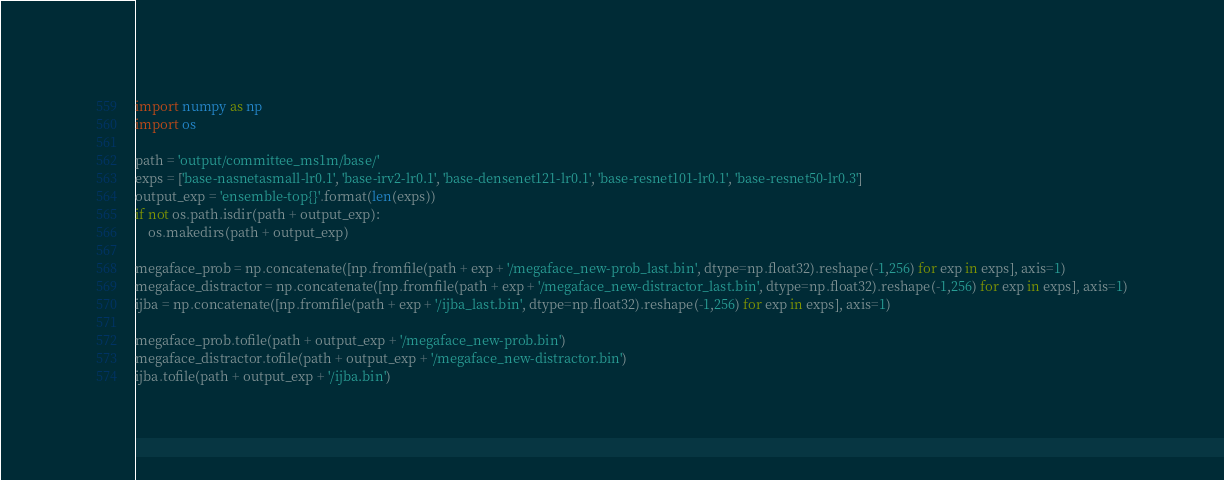Convert code to text. <code><loc_0><loc_0><loc_500><loc_500><_Python_>import numpy as np
import os

path = 'output/committee_ms1m/base/'
exps = ['base-nasnetasmall-lr0.1', 'base-irv2-lr0.1', 'base-densenet121-lr0.1', 'base-resnet101-lr0.1', 'base-resnet50-lr0.3']
output_exp = 'ensemble-top{}'.format(len(exps))
if not os.path.isdir(path + output_exp):
    os.makedirs(path + output_exp)

megaface_prob = np.concatenate([np.fromfile(path + exp + '/megaface_new-prob_last.bin', dtype=np.float32).reshape(-1,256) for exp in exps], axis=1)
megaface_distractor = np.concatenate([np.fromfile(path + exp + '/megaface_new-distractor_last.bin', dtype=np.float32).reshape(-1,256) for exp in exps], axis=1)
ijba = np.concatenate([np.fromfile(path + exp + '/ijba_last.bin', dtype=np.float32).reshape(-1,256) for exp in exps], axis=1)

megaface_prob.tofile(path + output_exp + '/megaface_new-prob.bin')
megaface_distractor.tofile(path + output_exp + '/megaface_new-distractor.bin')
ijba.tofile(path + output_exp + '/ijba.bin')
</code> 